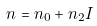Convert formula to latex. <formula><loc_0><loc_0><loc_500><loc_500>n = n _ { 0 } + n _ { 2 } I</formula> 